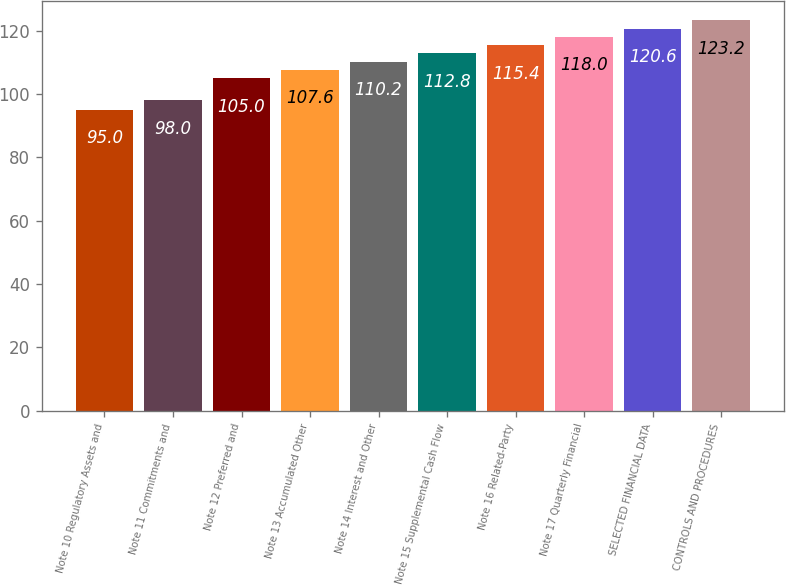Convert chart. <chart><loc_0><loc_0><loc_500><loc_500><bar_chart><fcel>Note 10 Regulatory Assets and<fcel>Note 11 Commitments and<fcel>Note 12 Preferred and<fcel>Note 13 Accumulated Other<fcel>Note 14 Interest and Other<fcel>Note 15 Supplemental Cash Flow<fcel>Note 16 Related-Party<fcel>Note 17 Quarterly Financial<fcel>SELECTED FINANCIAL DATA<fcel>CONTROLS AND PROCEDURES<nl><fcel>95<fcel>98<fcel>105<fcel>107.6<fcel>110.2<fcel>112.8<fcel>115.4<fcel>118<fcel>120.6<fcel>123.2<nl></chart> 